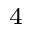<formula> <loc_0><loc_0><loc_500><loc_500>^ { 4 }</formula> 